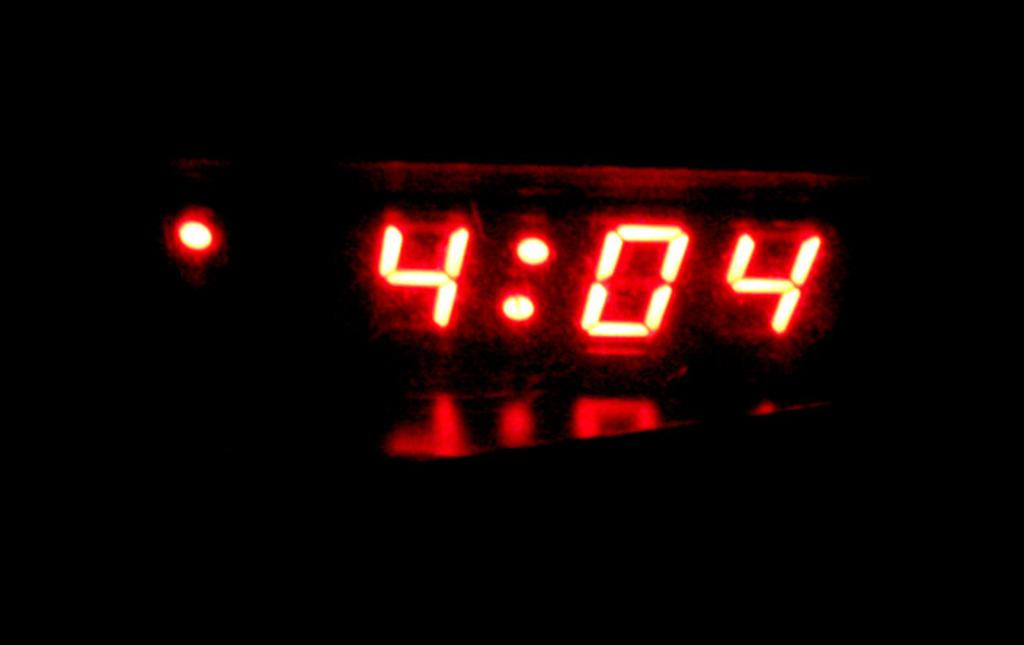<image>
Describe the image concisely. Digital cock showing the time at 4:04 in a dark room. 